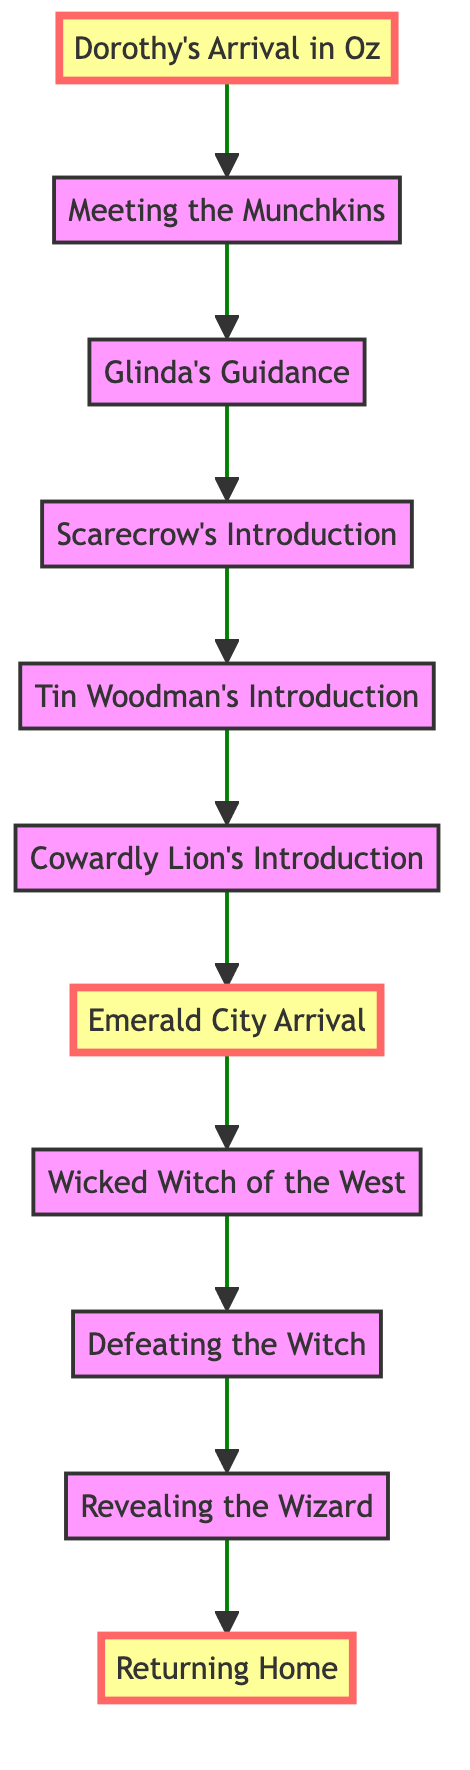What is the first event in the plot? The first event in the plot is Dorothy's Arrival in Oz, as indicated by the node labeled "Dorothy's Arrival in Oz," which is the starting point of the diagram.
Answer: Dorothy's Arrival in Oz How many major events are depicted in the diagram? Counting the nodes, there are 11 major events shown in the diagram, each representing a significant moment in the plot.
Answer: 11 What event directly follows Dorothy's encounter with the Munchkins? The event that directly follows Dorothy's encounter with the Munchkins is Glinda's Guidance, as indicated by the directed edge from node 2 to node 3.
Answer: Glinda's Guidance What three companions does Dorothy meet on her journey? As indicated in the diagram, the three companions are the Scarecrow, the Tin Woodman, and the Cowardly Lion, shown in sequential nodes 4, 5, and 6.
Answer: Scarecrow, Tin Woodman, Cowardly Lion What task does the Wizard assign to Dorothy and her friends? The Wizard tasks them with defeating the Wicked Witch of the West, which is clearly stated in the node labeled "Wicked Witch of the West."
Answer: Defeating the Wicked Witch of the West Which two events are marked as important in the diagram? The important events highlighted are "Dorothy's Arrival in Oz" and "Returning Home," indicated by the styling in the respective nodes.
Answer: Dorothy's Arrival in Oz, Returning Home What event leads to the revelation of the Wizard? The event that leads to the revelation of the Wizard is "Defeating the Witch," as noted in the sequence just before the revelation node in the flow.
Answer: Defeating the Witch How are the events connected or sequenced in the diagram? The events are connected by directed edges that show a linear progression from one event to the next, starting with Dorothy's arrival and ending with her return home.
Answer: Linear progression What is the last event in the narrative according to the diagram? The last event in the narrative is "Returning Home," which is the endpoint of the flow and indicates Dorothy's closure to her adventure.
Answer: Returning Home 